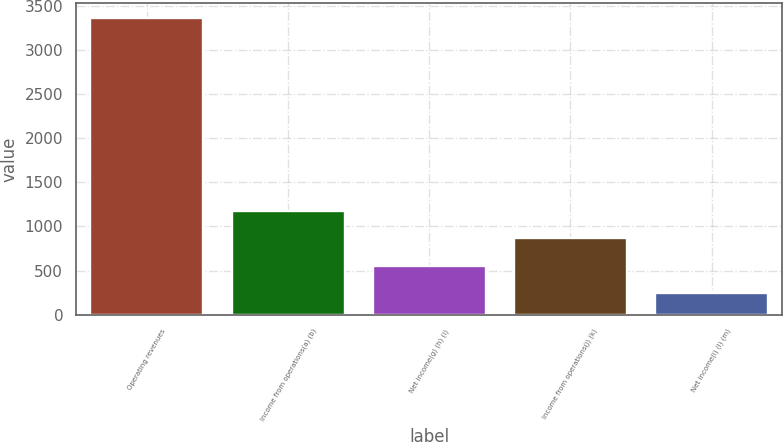<chart> <loc_0><loc_0><loc_500><loc_500><bar_chart><fcel>Operating revenues<fcel>Income from operations(a) (b)<fcel>Net income(g) (h) (i)<fcel>Income from operations(j) (k)<fcel>Net income(i) (l) (m)<nl><fcel>3361<fcel>1180.5<fcel>557.5<fcel>869<fcel>246<nl></chart> 